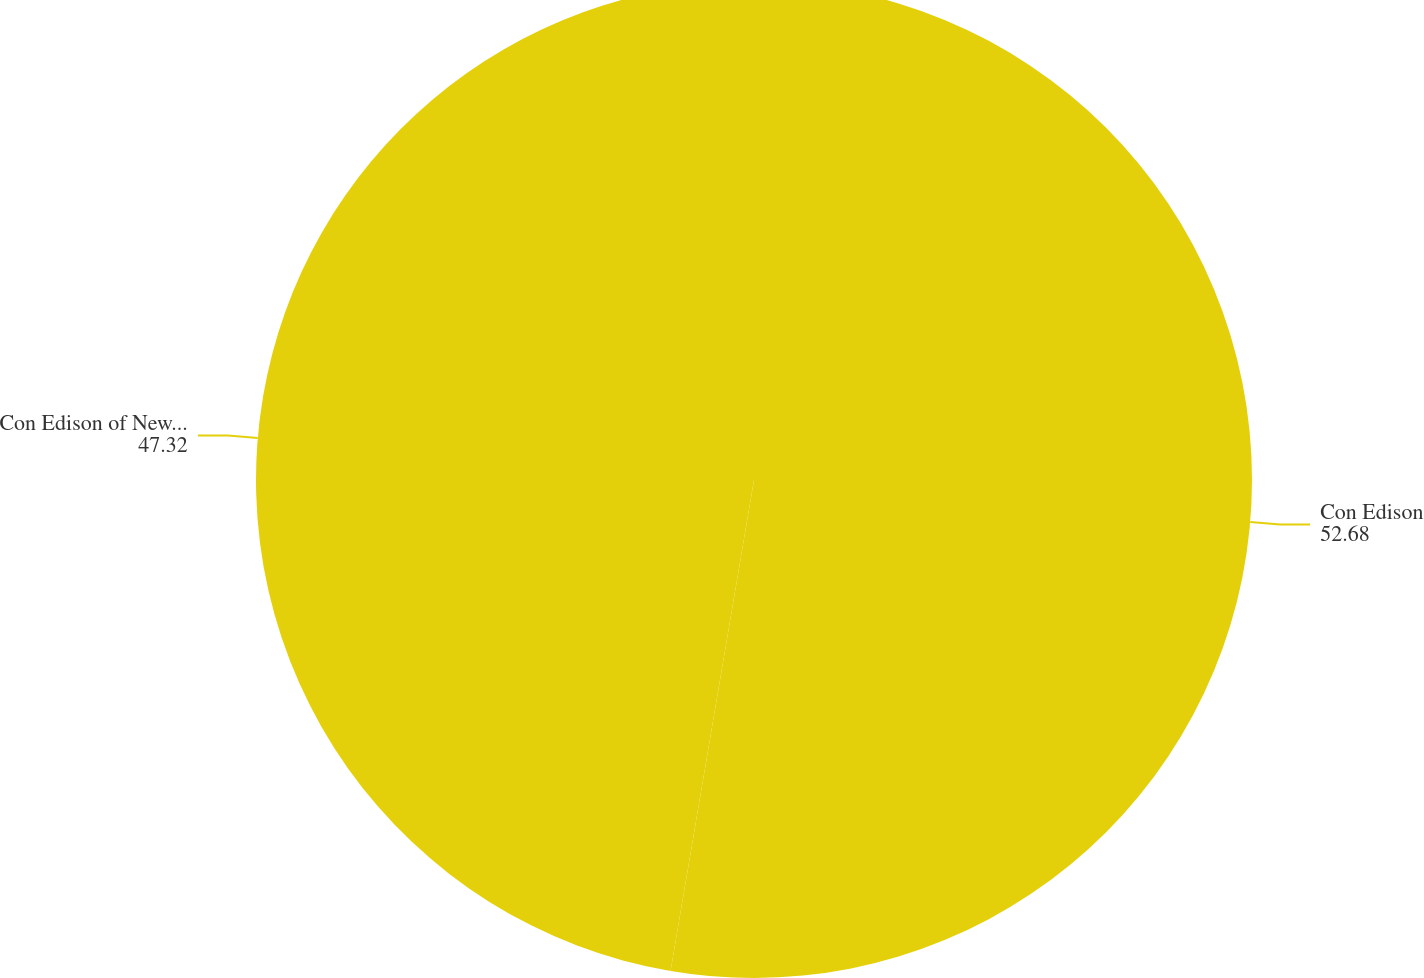Convert chart. <chart><loc_0><loc_0><loc_500><loc_500><pie_chart><fcel>Con Edison<fcel>Con Edison of New York<nl><fcel>52.68%<fcel>47.32%<nl></chart> 